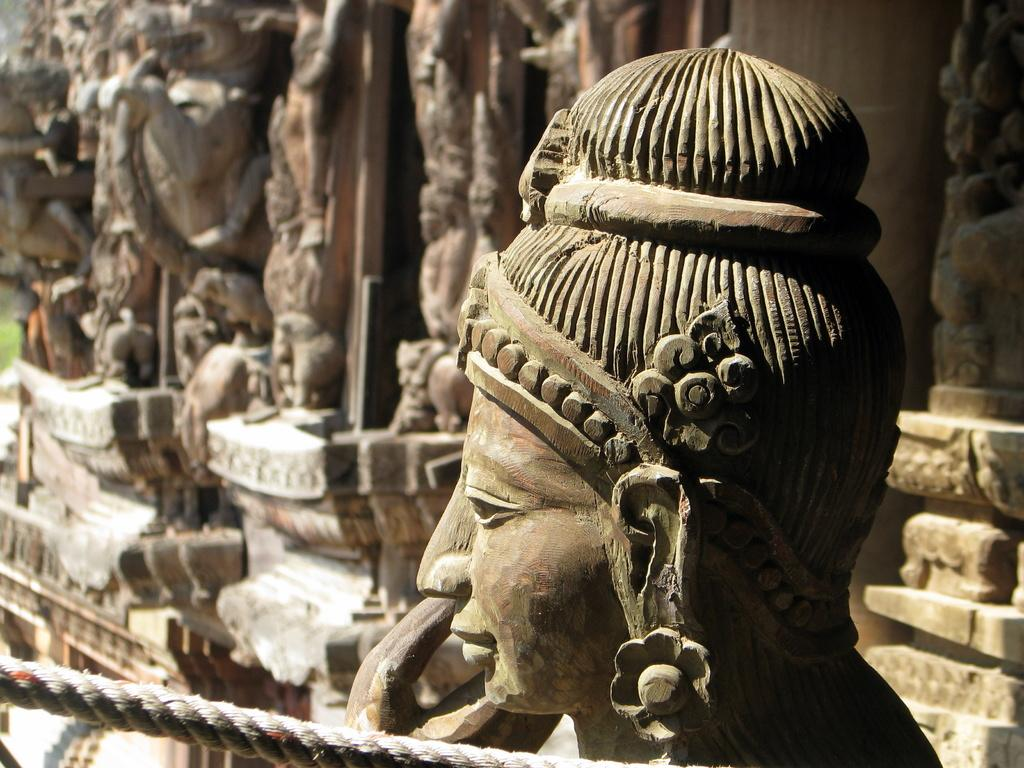What can be seen in the image that represents artistic creations? There are statues in the image. Can you describe the color of one of the statues? One statue is in brown color. What type of natural environment is visible in the image? There is green-colored grass in the image. What type of cloud is depicted in the image? There is no cloud present in the image; it only features statues and green-colored grass. What items are listed in a jar in the image? There is no jar present in the image, so it is not possible to answer that question. 